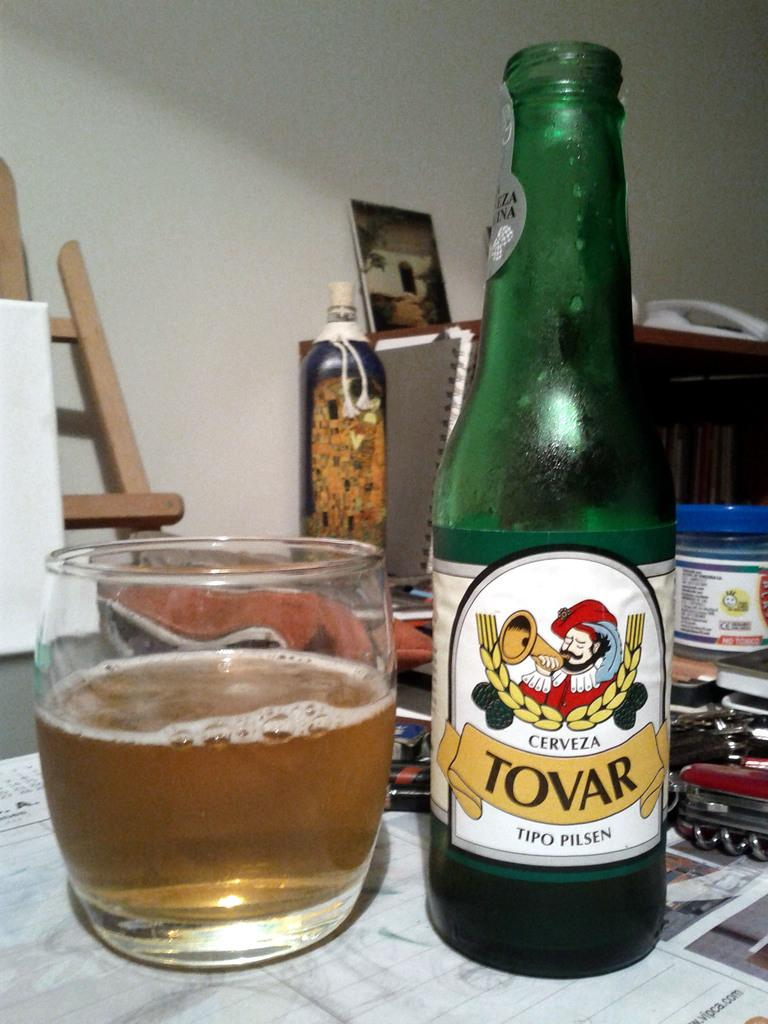<image>
Share a concise interpretation of the image provided. A bottle of Tovar beer is next to a glass with beer in it. 